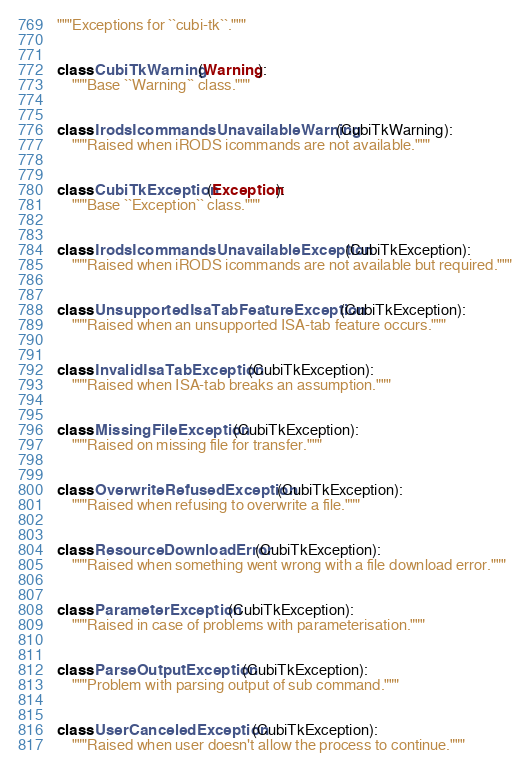<code> <loc_0><loc_0><loc_500><loc_500><_Python_>"""Exceptions for ``cubi-tk``."""


class CubiTkWarning(Warning):
    """Base ``Warning`` class."""


class IrodsIcommandsUnavailableWarning(CubiTkWarning):
    """Raised when iRODS icommands are not available."""


class CubiTkException(Exception):
    """Base ``Exception`` class."""


class IrodsIcommandsUnavailableException(CubiTkException):
    """Raised when iRODS icommands are not available but required."""


class UnsupportedIsaTabFeatureException(CubiTkException):
    """Raised when an unsupported ISA-tab feature occurs."""


class InvalidIsaTabException(CubiTkException):
    """Raised when ISA-tab breaks an assumption."""


class MissingFileException(CubiTkException):
    """Raised on missing file for transfer."""


class OverwriteRefusedException(CubiTkException):
    """Raised when refusing to overwrite a file."""


class ResourceDownloadError(CubiTkException):
    """Raised when something went wrong with a file download error."""


class ParameterException(CubiTkException):
    """Raised in case of problems with parameterisation."""


class ParseOutputException(CubiTkException):
    """Problem with parsing output of sub command."""


class UserCanceledException(CubiTkException):
    """Raised when user doesn't allow the process to continue."""
</code> 